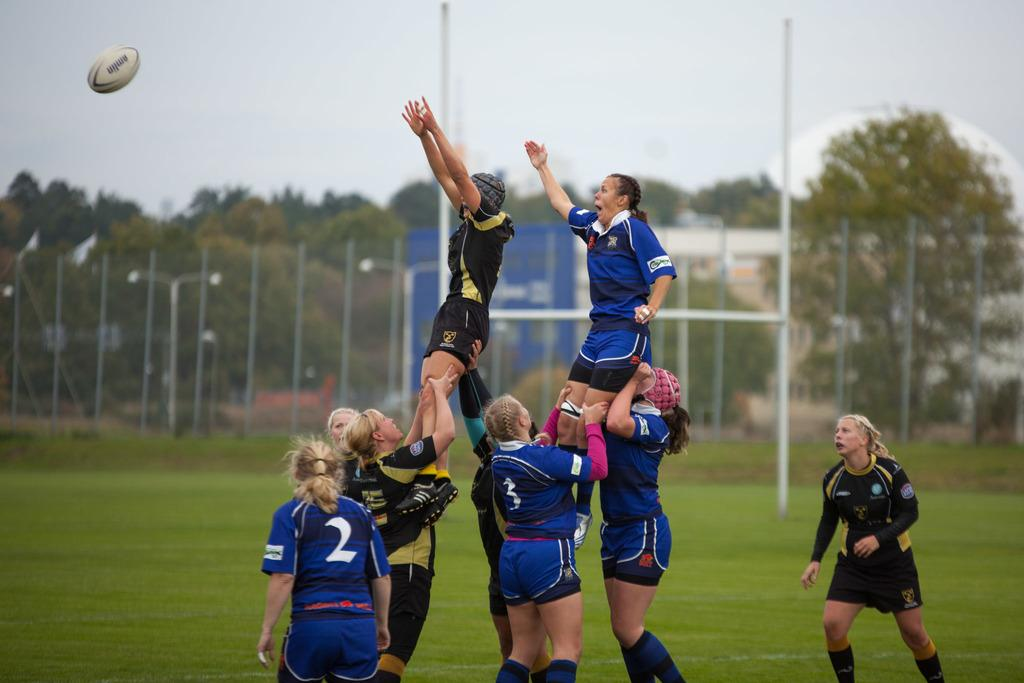Provide a one-sentence caption for the provided image. Women playing rugby in full uniforms one player is number two and one is three, two players are being lifted. 